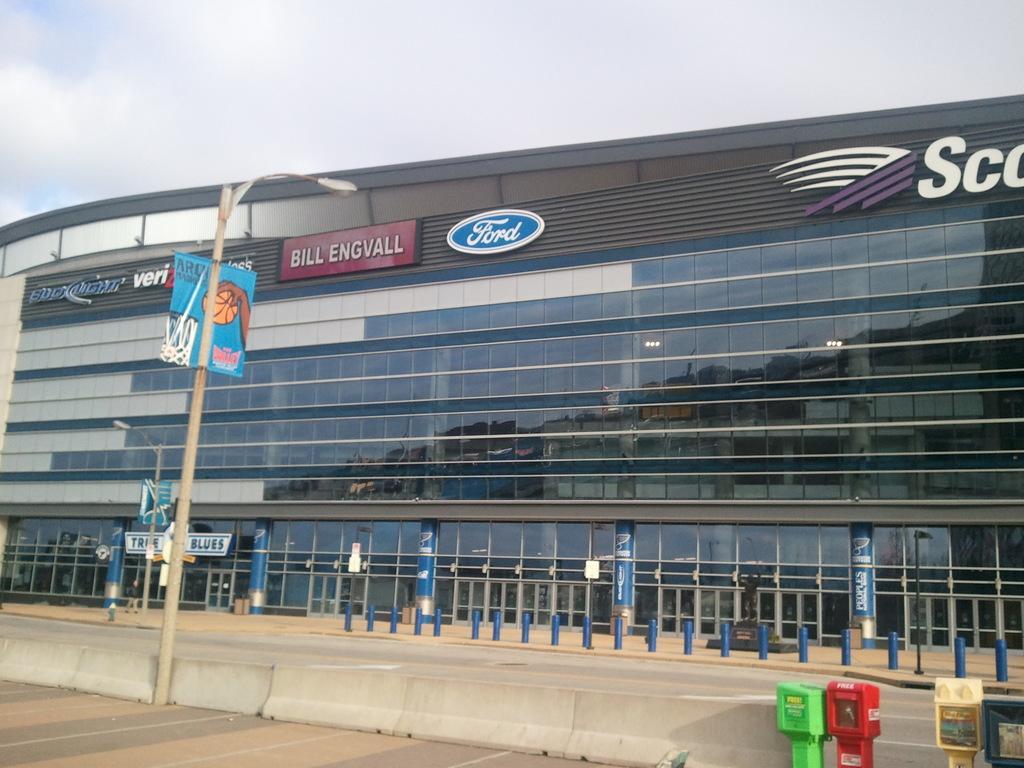Can you describe this image briefly? In this picture I can see a building. I can see poles, boards, lights and some other objects, and in the background there is the sky. 